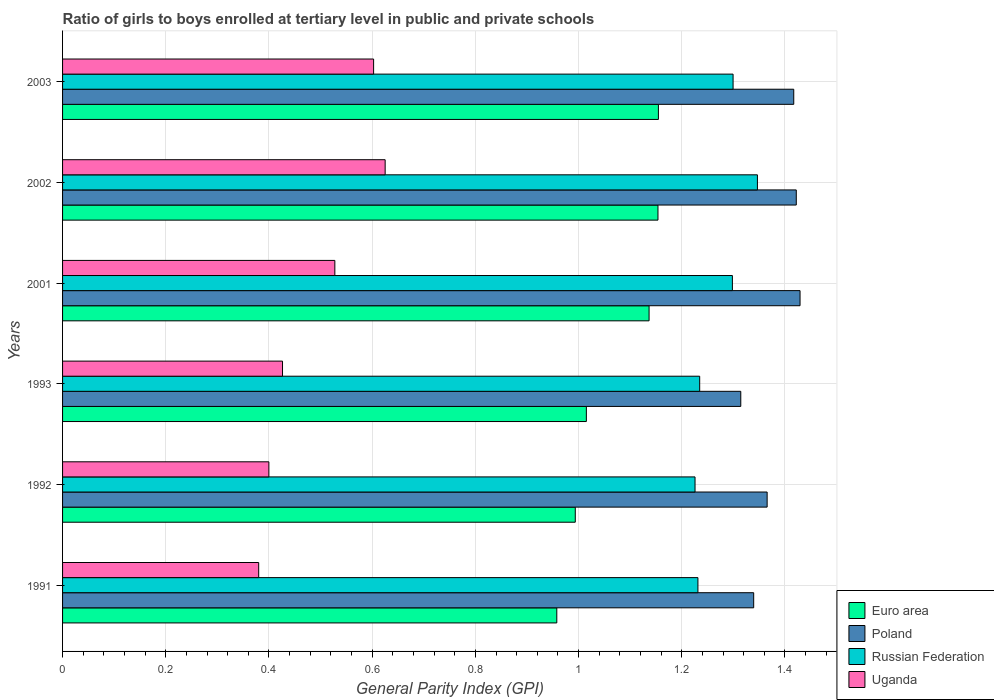How many different coloured bars are there?
Offer a terse response. 4. How many groups of bars are there?
Your response must be concise. 6. Are the number of bars on each tick of the Y-axis equal?
Provide a succinct answer. Yes. How many bars are there on the 6th tick from the bottom?
Offer a very short reply. 4. What is the label of the 5th group of bars from the top?
Your answer should be compact. 1992. In how many cases, is the number of bars for a given year not equal to the number of legend labels?
Ensure brevity in your answer.  0. What is the general parity index in Russian Federation in 1992?
Your response must be concise. 1.23. Across all years, what is the maximum general parity index in Poland?
Make the answer very short. 1.43. Across all years, what is the minimum general parity index in Russian Federation?
Ensure brevity in your answer.  1.23. In which year was the general parity index in Poland maximum?
Make the answer very short. 2001. In which year was the general parity index in Russian Federation minimum?
Your response must be concise. 1992. What is the total general parity index in Uganda in the graph?
Make the answer very short. 2.96. What is the difference between the general parity index in Russian Federation in 2001 and that in 2003?
Your answer should be compact. -0. What is the difference between the general parity index in Poland in 1991 and the general parity index in Uganda in 2001?
Your answer should be compact. 0.81. What is the average general parity index in Poland per year?
Keep it short and to the point. 1.38. In the year 2001, what is the difference between the general parity index in Uganda and general parity index in Euro area?
Give a very brief answer. -0.61. In how many years, is the general parity index in Euro area greater than 1.04 ?
Provide a short and direct response. 3. What is the ratio of the general parity index in Uganda in 1991 to that in 2001?
Give a very brief answer. 0.72. Is the difference between the general parity index in Uganda in 1991 and 2001 greater than the difference between the general parity index in Euro area in 1991 and 2001?
Your answer should be very brief. Yes. What is the difference between the highest and the second highest general parity index in Russian Federation?
Your answer should be compact. 0.05. What is the difference between the highest and the lowest general parity index in Uganda?
Provide a short and direct response. 0.25. Is the sum of the general parity index in Poland in 1991 and 2002 greater than the maximum general parity index in Euro area across all years?
Give a very brief answer. Yes. Is it the case that in every year, the sum of the general parity index in Euro area and general parity index in Uganda is greater than the sum of general parity index in Russian Federation and general parity index in Poland?
Offer a terse response. No. What does the 2nd bar from the top in 1993 represents?
Keep it short and to the point. Russian Federation. What does the 3rd bar from the bottom in 1991 represents?
Your answer should be very brief. Russian Federation. Are the values on the major ticks of X-axis written in scientific E-notation?
Your response must be concise. No. How many legend labels are there?
Offer a very short reply. 4. What is the title of the graph?
Your answer should be compact. Ratio of girls to boys enrolled at tertiary level in public and private schools. What is the label or title of the X-axis?
Give a very brief answer. General Parity Index (GPI). What is the label or title of the Y-axis?
Your response must be concise. Years. What is the General Parity Index (GPI) in Euro area in 1991?
Your answer should be compact. 0.96. What is the General Parity Index (GPI) in Poland in 1991?
Provide a short and direct response. 1.34. What is the General Parity Index (GPI) in Russian Federation in 1991?
Your answer should be compact. 1.23. What is the General Parity Index (GPI) in Uganda in 1991?
Your response must be concise. 0.38. What is the General Parity Index (GPI) in Euro area in 1992?
Provide a succinct answer. 0.99. What is the General Parity Index (GPI) of Poland in 1992?
Provide a succinct answer. 1.37. What is the General Parity Index (GPI) of Russian Federation in 1992?
Your answer should be very brief. 1.23. What is the General Parity Index (GPI) in Uganda in 1992?
Make the answer very short. 0.4. What is the General Parity Index (GPI) in Euro area in 1993?
Provide a succinct answer. 1.02. What is the General Parity Index (GPI) of Poland in 1993?
Provide a short and direct response. 1.31. What is the General Parity Index (GPI) in Russian Federation in 1993?
Your answer should be compact. 1.23. What is the General Parity Index (GPI) in Uganda in 1993?
Offer a very short reply. 0.43. What is the General Parity Index (GPI) in Euro area in 2001?
Keep it short and to the point. 1.14. What is the General Parity Index (GPI) of Poland in 2001?
Offer a very short reply. 1.43. What is the General Parity Index (GPI) of Russian Federation in 2001?
Offer a terse response. 1.3. What is the General Parity Index (GPI) of Uganda in 2001?
Your response must be concise. 0.53. What is the General Parity Index (GPI) in Euro area in 2002?
Your answer should be very brief. 1.15. What is the General Parity Index (GPI) in Poland in 2002?
Offer a terse response. 1.42. What is the General Parity Index (GPI) in Russian Federation in 2002?
Provide a succinct answer. 1.35. What is the General Parity Index (GPI) in Uganda in 2002?
Provide a short and direct response. 0.63. What is the General Parity Index (GPI) in Euro area in 2003?
Give a very brief answer. 1.15. What is the General Parity Index (GPI) of Poland in 2003?
Offer a terse response. 1.42. What is the General Parity Index (GPI) in Russian Federation in 2003?
Offer a terse response. 1.3. What is the General Parity Index (GPI) in Uganda in 2003?
Provide a succinct answer. 0.6. Across all years, what is the maximum General Parity Index (GPI) in Euro area?
Provide a short and direct response. 1.15. Across all years, what is the maximum General Parity Index (GPI) of Poland?
Your answer should be compact. 1.43. Across all years, what is the maximum General Parity Index (GPI) in Russian Federation?
Offer a terse response. 1.35. Across all years, what is the maximum General Parity Index (GPI) of Uganda?
Keep it short and to the point. 0.63. Across all years, what is the minimum General Parity Index (GPI) of Euro area?
Ensure brevity in your answer.  0.96. Across all years, what is the minimum General Parity Index (GPI) of Poland?
Your answer should be compact. 1.31. Across all years, what is the minimum General Parity Index (GPI) of Russian Federation?
Offer a terse response. 1.23. Across all years, what is the minimum General Parity Index (GPI) of Uganda?
Provide a short and direct response. 0.38. What is the total General Parity Index (GPI) of Euro area in the graph?
Your answer should be compact. 6.41. What is the total General Parity Index (GPI) of Poland in the graph?
Keep it short and to the point. 8.29. What is the total General Parity Index (GPI) of Russian Federation in the graph?
Your answer should be compact. 7.64. What is the total General Parity Index (GPI) in Uganda in the graph?
Keep it short and to the point. 2.96. What is the difference between the General Parity Index (GPI) in Euro area in 1991 and that in 1992?
Keep it short and to the point. -0.04. What is the difference between the General Parity Index (GPI) of Poland in 1991 and that in 1992?
Provide a succinct answer. -0.03. What is the difference between the General Parity Index (GPI) of Russian Federation in 1991 and that in 1992?
Keep it short and to the point. 0.01. What is the difference between the General Parity Index (GPI) in Uganda in 1991 and that in 1992?
Your answer should be compact. -0.02. What is the difference between the General Parity Index (GPI) of Euro area in 1991 and that in 1993?
Offer a very short reply. -0.06. What is the difference between the General Parity Index (GPI) in Poland in 1991 and that in 1993?
Provide a succinct answer. 0.03. What is the difference between the General Parity Index (GPI) of Russian Federation in 1991 and that in 1993?
Give a very brief answer. -0. What is the difference between the General Parity Index (GPI) of Uganda in 1991 and that in 1993?
Keep it short and to the point. -0.05. What is the difference between the General Parity Index (GPI) of Euro area in 1991 and that in 2001?
Offer a very short reply. -0.18. What is the difference between the General Parity Index (GPI) in Poland in 1991 and that in 2001?
Your response must be concise. -0.09. What is the difference between the General Parity Index (GPI) of Russian Federation in 1991 and that in 2001?
Offer a very short reply. -0.07. What is the difference between the General Parity Index (GPI) of Uganda in 1991 and that in 2001?
Keep it short and to the point. -0.15. What is the difference between the General Parity Index (GPI) in Euro area in 1991 and that in 2002?
Your response must be concise. -0.2. What is the difference between the General Parity Index (GPI) in Poland in 1991 and that in 2002?
Your response must be concise. -0.08. What is the difference between the General Parity Index (GPI) of Russian Federation in 1991 and that in 2002?
Give a very brief answer. -0.12. What is the difference between the General Parity Index (GPI) of Uganda in 1991 and that in 2002?
Your answer should be compact. -0.25. What is the difference between the General Parity Index (GPI) of Euro area in 1991 and that in 2003?
Your answer should be very brief. -0.2. What is the difference between the General Parity Index (GPI) in Poland in 1991 and that in 2003?
Your answer should be compact. -0.08. What is the difference between the General Parity Index (GPI) of Russian Federation in 1991 and that in 2003?
Give a very brief answer. -0.07. What is the difference between the General Parity Index (GPI) in Uganda in 1991 and that in 2003?
Your answer should be compact. -0.22. What is the difference between the General Parity Index (GPI) in Euro area in 1992 and that in 1993?
Make the answer very short. -0.02. What is the difference between the General Parity Index (GPI) in Poland in 1992 and that in 1993?
Give a very brief answer. 0.05. What is the difference between the General Parity Index (GPI) of Russian Federation in 1992 and that in 1993?
Your response must be concise. -0.01. What is the difference between the General Parity Index (GPI) in Uganda in 1992 and that in 1993?
Offer a terse response. -0.03. What is the difference between the General Parity Index (GPI) of Euro area in 1992 and that in 2001?
Make the answer very short. -0.14. What is the difference between the General Parity Index (GPI) of Poland in 1992 and that in 2001?
Give a very brief answer. -0.06. What is the difference between the General Parity Index (GPI) in Russian Federation in 1992 and that in 2001?
Offer a very short reply. -0.07. What is the difference between the General Parity Index (GPI) in Uganda in 1992 and that in 2001?
Your answer should be compact. -0.13. What is the difference between the General Parity Index (GPI) in Euro area in 1992 and that in 2002?
Ensure brevity in your answer.  -0.16. What is the difference between the General Parity Index (GPI) in Poland in 1992 and that in 2002?
Make the answer very short. -0.06. What is the difference between the General Parity Index (GPI) of Russian Federation in 1992 and that in 2002?
Offer a very short reply. -0.12. What is the difference between the General Parity Index (GPI) in Uganda in 1992 and that in 2002?
Your answer should be compact. -0.23. What is the difference between the General Parity Index (GPI) of Euro area in 1992 and that in 2003?
Keep it short and to the point. -0.16. What is the difference between the General Parity Index (GPI) in Poland in 1992 and that in 2003?
Offer a terse response. -0.05. What is the difference between the General Parity Index (GPI) of Russian Federation in 1992 and that in 2003?
Ensure brevity in your answer.  -0.07. What is the difference between the General Parity Index (GPI) in Uganda in 1992 and that in 2003?
Give a very brief answer. -0.2. What is the difference between the General Parity Index (GPI) of Euro area in 1993 and that in 2001?
Ensure brevity in your answer.  -0.12. What is the difference between the General Parity Index (GPI) in Poland in 1993 and that in 2001?
Your answer should be compact. -0.11. What is the difference between the General Parity Index (GPI) of Russian Federation in 1993 and that in 2001?
Make the answer very short. -0.06. What is the difference between the General Parity Index (GPI) in Uganda in 1993 and that in 2001?
Provide a short and direct response. -0.1. What is the difference between the General Parity Index (GPI) in Euro area in 1993 and that in 2002?
Your answer should be compact. -0.14. What is the difference between the General Parity Index (GPI) in Poland in 1993 and that in 2002?
Offer a very short reply. -0.11. What is the difference between the General Parity Index (GPI) of Russian Federation in 1993 and that in 2002?
Offer a terse response. -0.11. What is the difference between the General Parity Index (GPI) in Uganda in 1993 and that in 2002?
Your response must be concise. -0.2. What is the difference between the General Parity Index (GPI) of Euro area in 1993 and that in 2003?
Offer a very short reply. -0.14. What is the difference between the General Parity Index (GPI) of Poland in 1993 and that in 2003?
Provide a succinct answer. -0.1. What is the difference between the General Parity Index (GPI) of Russian Federation in 1993 and that in 2003?
Make the answer very short. -0.06. What is the difference between the General Parity Index (GPI) of Uganda in 1993 and that in 2003?
Your answer should be very brief. -0.18. What is the difference between the General Parity Index (GPI) in Euro area in 2001 and that in 2002?
Give a very brief answer. -0.02. What is the difference between the General Parity Index (GPI) in Poland in 2001 and that in 2002?
Your response must be concise. 0.01. What is the difference between the General Parity Index (GPI) of Russian Federation in 2001 and that in 2002?
Provide a succinct answer. -0.05. What is the difference between the General Parity Index (GPI) of Uganda in 2001 and that in 2002?
Offer a terse response. -0.1. What is the difference between the General Parity Index (GPI) in Euro area in 2001 and that in 2003?
Provide a succinct answer. -0.02. What is the difference between the General Parity Index (GPI) of Poland in 2001 and that in 2003?
Your response must be concise. 0.01. What is the difference between the General Parity Index (GPI) of Russian Federation in 2001 and that in 2003?
Offer a terse response. -0. What is the difference between the General Parity Index (GPI) in Uganda in 2001 and that in 2003?
Make the answer very short. -0.08. What is the difference between the General Parity Index (GPI) in Euro area in 2002 and that in 2003?
Keep it short and to the point. -0. What is the difference between the General Parity Index (GPI) of Poland in 2002 and that in 2003?
Provide a short and direct response. 0. What is the difference between the General Parity Index (GPI) of Russian Federation in 2002 and that in 2003?
Provide a succinct answer. 0.05. What is the difference between the General Parity Index (GPI) in Uganda in 2002 and that in 2003?
Provide a succinct answer. 0.02. What is the difference between the General Parity Index (GPI) in Euro area in 1991 and the General Parity Index (GPI) in Poland in 1992?
Your answer should be compact. -0.41. What is the difference between the General Parity Index (GPI) of Euro area in 1991 and the General Parity Index (GPI) of Russian Federation in 1992?
Keep it short and to the point. -0.27. What is the difference between the General Parity Index (GPI) in Euro area in 1991 and the General Parity Index (GPI) in Uganda in 1992?
Offer a terse response. 0.56. What is the difference between the General Parity Index (GPI) in Poland in 1991 and the General Parity Index (GPI) in Russian Federation in 1992?
Make the answer very short. 0.11. What is the difference between the General Parity Index (GPI) in Poland in 1991 and the General Parity Index (GPI) in Uganda in 1992?
Ensure brevity in your answer.  0.94. What is the difference between the General Parity Index (GPI) in Russian Federation in 1991 and the General Parity Index (GPI) in Uganda in 1992?
Provide a succinct answer. 0.83. What is the difference between the General Parity Index (GPI) in Euro area in 1991 and the General Parity Index (GPI) in Poland in 1993?
Ensure brevity in your answer.  -0.36. What is the difference between the General Parity Index (GPI) of Euro area in 1991 and the General Parity Index (GPI) of Russian Federation in 1993?
Offer a terse response. -0.28. What is the difference between the General Parity Index (GPI) in Euro area in 1991 and the General Parity Index (GPI) in Uganda in 1993?
Offer a terse response. 0.53. What is the difference between the General Parity Index (GPI) of Poland in 1991 and the General Parity Index (GPI) of Russian Federation in 1993?
Make the answer very short. 0.1. What is the difference between the General Parity Index (GPI) in Poland in 1991 and the General Parity Index (GPI) in Uganda in 1993?
Offer a terse response. 0.91. What is the difference between the General Parity Index (GPI) of Russian Federation in 1991 and the General Parity Index (GPI) of Uganda in 1993?
Keep it short and to the point. 0.81. What is the difference between the General Parity Index (GPI) of Euro area in 1991 and the General Parity Index (GPI) of Poland in 2001?
Provide a succinct answer. -0.47. What is the difference between the General Parity Index (GPI) in Euro area in 1991 and the General Parity Index (GPI) in Russian Federation in 2001?
Give a very brief answer. -0.34. What is the difference between the General Parity Index (GPI) in Euro area in 1991 and the General Parity Index (GPI) in Uganda in 2001?
Ensure brevity in your answer.  0.43. What is the difference between the General Parity Index (GPI) of Poland in 1991 and the General Parity Index (GPI) of Russian Federation in 2001?
Your answer should be very brief. 0.04. What is the difference between the General Parity Index (GPI) of Poland in 1991 and the General Parity Index (GPI) of Uganda in 2001?
Ensure brevity in your answer.  0.81. What is the difference between the General Parity Index (GPI) of Russian Federation in 1991 and the General Parity Index (GPI) of Uganda in 2001?
Provide a succinct answer. 0.7. What is the difference between the General Parity Index (GPI) in Euro area in 1991 and the General Parity Index (GPI) in Poland in 2002?
Give a very brief answer. -0.46. What is the difference between the General Parity Index (GPI) of Euro area in 1991 and the General Parity Index (GPI) of Russian Federation in 2002?
Offer a very short reply. -0.39. What is the difference between the General Parity Index (GPI) in Euro area in 1991 and the General Parity Index (GPI) in Uganda in 2002?
Your answer should be very brief. 0.33. What is the difference between the General Parity Index (GPI) of Poland in 1991 and the General Parity Index (GPI) of Russian Federation in 2002?
Provide a succinct answer. -0.01. What is the difference between the General Parity Index (GPI) in Poland in 1991 and the General Parity Index (GPI) in Uganda in 2002?
Your answer should be very brief. 0.71. What is the difference between the General Parity Index (GPI) of Russian Federation in 1991 and the General Parity Index (GPI) of Uganda in 2002?
Offer a very short reply. 0.61. What is the difference between the General Parity Index (GPI) of Euro area in 1991 and the General Parity Index (GPI) of Poland in 2003?
Offer a terse response. -0.46. What is the difference between the General Parity Index (GPI) in Euro area in 1991 and the General Parity Index (GPI) in Russian Federation in 2003?
Offer a terse response. -0.34. What is the difference between the General Parity Index (GPI) in Euro area in 1991 and the General Parity Index (GPI) in Uganda in 2003?
Keep it short and to the point. 0.35. What is the difference between the General Parity Index (GPI) in Poland in 1991 and the General Parity Index (GPI) in Russian Federation in 2003?
Provide a succinct answer. 0.04. What is the difference between the General Parity Index (GPI) of Poland in 1991 and the General Parity Index (GPI) of Uganda in 2003?
Offer a terse response. 0.74. What is the difference between the General Parity Index (GPI) in Russian Federation in 1991 and the General Parity Index (GPI) in Uganda in 2003?
Keep it short and to the point. 0.63. What is the difference between the General Parity Index (GPI) of Euro area in 1992 and the General Parity Index (GPI) of Poland in 1993?
Keep it short and to the point. -0.32. What is the difference between the General Parity Index (GPI) of Euro area in 1992 and the General Parity Index (GPI) of Russian Federation in 1993?
Your answer should be compact. -0.24. What is the difference between the General Parity Index (GPI) in Euro area in 1992 and the General Parity Index (GPI) in Uganda in 1993?
Provide a succinct answer. 0.57. What is the difference between the General Parity Index (GPI) in Poland in 1992 and the General Parity Index (GPI) in Russian Federation in 1993?
Ensure brevity in your answer.  0.13. What is the difference between the General Parity Index (GPI) of Poland in 1992 and the General Parity Index (GPI) of Uganda in 1993?
Keep it short and to the point. 0.94. What is the difference between the General Parity Index (GPI) in Russian Federation in 1992 and the General Parity Index (GPI) in Uganda in 1993?
Your response must be concise. 0.8. What is the difference between the General Parity Index (GPI) of Euro area in 1992 and the General Parity Index (GPI) of Poland in 2001?
Your response must be concise. -0.44. What is the difference between the General Parity Index (GPI) in Euro area in 1992 and the General Parity Index (GPI) in Russian Federation in 2001?
Ensure brevity in your answer.  -0.3. What is the difference between the General Parity Index (GPI) of Euro area in 1992 and the General Parity Index (GPI) of Uganda in 2001?
Keep it short and to the point. 0.47. What is the difference between the General Parity Index (GPI) in Poland in 1992 and the General Parity Index (GPI) in Russian Federation in 2001?
Provide a short and direct response. 0.07. What is the difference between the General Parity Index (GPI) of Poland in 1992 and the General Parity Index (GPI) of Uganda in 2001?
Offer a very short reply. 0.84. What is the difference between the General Parity Index (GPI) of Russian Federation in 1992 and the General Parity Index (GPI) of Uganda in 2001?
Keep it short and to the point. 0.7. What is the difference between the General Parity Index (GPI) of Euro area in 1992 and the General Parity Index (GPI) of Poland in 2002?
Ensure brevity in your answer.  -0.43. What is the difference between the General Parity Index (GPI) in Euro area in 1992 and the General Parity Index (GPI) in Russian Federation in 2002?
Your answer should be very brief. -0.35. What is the difference between the General Parity Index (GPI) of Euro area in 1992 and the General Parity Index (GPI) of Uganda in 2002?
Offer a very short reply. 0.37. What is the difference between the General Parity Index (GPI) of Poland in 1992 and the General Parity Index (GPI) of Russian Federation in 2002?
Offer a terse response. 0.02. What is the difference between the General Parity Index (GPI) in Poland in 1992 and the General Parity Index (GPI) in Uganda in 2002?
Your answer should be compact. 0.74. What is the difference between the General Parity Index (GPI) in Russian Federation in 1992 and the General Parity Index (GPI) in Uganda in 2002?
Offer a terse response. 0.6. What is the difference between the General Parity Index (GPI) of Euro area in 1992 and the General Parity Index (GPI) of Poland in 2003?
Offer a very short reply. -0.42. What is the difference between the General Parity Index (GPI) of Euro area in 1992 and the General Parity Index (GPI) of Russian Federation in 2003?
Offer a very short reply. -0.31. What is the difference between the General Parity Index (GPI) of Euro area in 1992 and the General Parity Index (GPI) of Uganda in 2003?
Offer a very short reply. 0.39. What is the difference between the General Parity Index (GPI) in Poland in 1992 and the General Parity Index (GPI) in Russian Federation in 2003?
Offer a terse response. 0.07. What is the difference between the General Parity Index (GPI) of Poland in 1992 and the General Parity Index (GPI) of Uganda in 2003?
Make the answer very short. 0.76. What is the difference between the General Parity Index (GPI) in Russian Federation in 1992 and the General Parity Index (GPI) in Uganda in 2003?
Your response must be concise. 0.62. What is the difference between the General Parity Index (GPI) of Euro area in 1993 and the General Parity Index (GPI) of Poland in 2001?
Provide a short and direct response. -0.41. What is the difference between the General Parity Index (GPI) of Euro area in 1993 and the General Parity Index (GPI) of Russian Federation in 2001?
Your response must be concise. -0.28. What is the difference between the General Parity Index (GPI) of Euro area in 1993 and the General Parity Index (GPI) of Uganda in 2001?
Your answer should be very brief. 0.49. What is the difference between the General Parity Index (GPI) in Poland in 1993 and the General Parity Index (GPI) in Russian Federation in 2001?
Give a very brief answer. 0.02. What is the difference between the General Parity Index (GPI) in Poland in 1993 and the General Parity Index (GPI) in Uganda in 2001?
Give a very brief answer. 0.79. What is the difference between the General Parity Index (GPI) in Russian Federation in 1993 and the General Parity Index (GPI) in Uganda in 2001?
Offer a terse response. 0.71. What is the difference between the General Parity Index (GPI) in Euro area in 1993 and the General Parity Index (GPI) in Poland in 2002?
Offer a terse response. -0.41. What is the difference between the General Parity Index (GPI) of Euro area in 1993 and the General Parity Index (GPI) of Russian Federation in 2002?
Your answer should be very brief. -0.33. What is the difference between the General Parity Index (GPI) in Euro area in 1993 and the General Parity Index (GPI) in Uganda in 2002?
Keep it short and to the point. 0.39. What is the difference between the General Parity Index (GPI) in Poland in 1993 and the General Parity Index (GPI) in Russian Federation in 2002?
Keep it short and to the point. -0.03. What is the difference between the General Parity Index (GPI) in Poland in 1993 and the General Parity Index (GPI) in Uganda in 2002?
Your response must be concise. 0.69. What is the difference between the General Parity Index (GPI) of Russian Federation in 1993 and the General Parity Index (GPI) of Uganda in 2002?
Give a very brief answer. 0.61. What is the difference between the General Parity Index (GPI) in Euro area in 1993 and the General Parity Index (GPI) in Poland in 2003?
Ensure brevity in your answer.  -0.4. What is the difference between the General Parity Index (GPI) of Euro area in 1993 and the General Parity Index (GPI) of Russian Federation in 2003?
Your answer should be very brief. -0.28. What is the difference between the General Parity Index (GPI) in Euro area in 1993 and the General Parity Index (GPI) in Uganda in 2003?
Keep it short and to the point. 0.41. What is the difference between the General Parity Index (GPI) of Poland in 1993 and the General Parity Index (GPI) of Russian Federation in 2003?
Offer a very short reply. 0.01. What is the difference between the General Parity Index (GPI) of Poland in 1993 and the General Parity Index (GPI) of Uganda in 2003?
Provide a succinct answer. 0.71. What is the difference between the General Parity Index (GPI) of Russian Federation in 1993 and the General Parity Index (GPI) of Uganda in 2003?
Provide a succinct answer. 0.63. What is the difference between the General Parity Index (GPI) of Euro area in 2001 and the General Parity Index (GPI) of Poland in 2002?
Offer a very short reply. -0.29. What is the difference between the General Parity Index (GPI) of Euro area in 2001 and the General Parity Index (GPI) of Russian Federation in 2002?
Make the answer very short. -0.21. What is the difference between the General Parity Index (GPI) of Euro area in 2001 and the General Parity Index (GPI) of Uganda in 2002?
Your answer should be very brief. 0.51. What is the difference between the General Parity Index (GPI) in Poland in 2001 and the General Parity Index (GPI) in Russian Federation in 2002?
Ensure brevity in your answer.  0.08. What is the difference between the General Parity Index (GPI) in Poland in 2001 and the General Parity Index (GPI) in Uganda in 2002?
Your answer should be compact. 0.8. What is the difference between the General Parity Index (GPI) in Russian Federation in 2001 and the General Parity Index (GPI) in Uganda in 2002?
Ensure brevity in your answer.  0.67. What is the difference between the General Parity Index (GPI) in Euro area in 2001 and the General Parity Index (GPI) in Poland in 2003?
Ensure brevity in your answer.  -0.28. What is the difference between the General Parity Index (GPI) in Euro area in 2001 and the General Parity Index (GPI) in Russian Federation in 2003?
Your response must be concise. -0.16. What is the difference between the General Parity Index (GPI) in Euro area in 2001 and the General Parity Index (GPI) in Uganda in 2003?
Give a very brief answer. 0.53. What is the difference between the General Parity Index (GPI) in Poland in 2001 and the General Parity Index (GPI) in Russian Federation in 2003?
Your answer should be very brief. 0.13. What is the difference between the General Parity Index (GPI) in Poland in 2001 and the General Parity Index (GPI) in Uganda in 2003?
Provide a succinct answer. 0.83. What is the difference between the General Parity Index (GPI) of Russian Federation in 2001 and the General Parity Index (GPI) of Uganda in 2003?
Provide a succinct answer. 0.7. What is the difference between the General Parity Index (GPI) in Euro area in 2002 and the General Parity Index (GPI) in Poland in 2003?
Make the answer very short. -0.26. What is the difference between the General Parity Index (GPI) in Euro area in 2002 and the General Parity Index (GPI) in Russian Federation in 2003?
Your response must be concise. -0.15. What is the difference between the General Parity Index (GPI) of Euro area in 2002 and the General Parity Index (GPI) of Uganda in 2003?
Your answer should be compact. 0.55. What is the difference between the General Parity Index (GPI) of Poland in 2002 and the General Parity Index (GPI) of Russian Federation in 2003?
Your answer should be compact. 0.12. What is the difference between the General Parity Index (GPI) in Poland in 2002 and the General Parity Index (GPI) in Uganda in 2003?
Offer a terse response. 0.82. What is the difference between the General Parity Index (GPI) of Russian Federation in 2002 and the General Parity Index (GPI) of Uganda in 2003?
Keep it short and to the point. 0.74. What is the average General Parity Index (GPI) of Euro area per year?
Provide a succinct answer. 1.07. What is the average General Parity Index (GPI) in Poland per year?
Keep it short and to the point. 1.38. What is the average General Parity Index (GPI) in Russian Federation per year?
Offer a very short reply. 1.27. What is the average General Parity Index (GPI) of Uganda per year?
Make the answer very short. 0.49. In the year 1991, what is the difference between the General Parity Index (GPI) of Euro area and General Parity Index (GPI) of Poland?
Ensure brevity in your answer.  -0.38. In the year 1991, what is the difference between the General Parity Index (GPI) of Euro area and General Parity Index (GPI) of Russian Federation?
Give a very brief answer. -0.27. In the year 1991, what is the difference between the General Parity Index (GPI) of Euro area and General Parity Index (GPI) of Uganda?
Provide a short and direct response. 0.58. In the year 1991, what is the difference between the General Parity Index (GPI) of Poland and General Parity Index (GPI) of Russian Federation?
Offer a very short reply. 0.11. In the year 1991, what is the difference between the General Parity Index (GPI) of Poland and General Parity Index (GPI) of Uganda?
Make the answer very short. 0.96. In the year 1991, what is the difference between the General Parity Index (GPI) in Russian Federation and General Parity Index (GPI) in Uganda?
Provide a short and direct response. 0.85. In the year 1992, what is the difference between the General Parity Index (GPI) in Euro area and General Parity Index (GPI) in Poland?
Provide a succinct answer. -0.37. In the year 1992, what is the difference between the General Parity Index (GPI) in Euro area and General Parity Index (GPI) in Russian Federation?
Provide a short and direct response. -0.23. In the year 1992, what is the difference between the General Parity Index (GPI) in Euro area and General Parity Index (GPI) in Uganda?
Offer a terse response. 0.59. In the year 1992, what is the difference between the General Parity Index (GPI) of Poland and General Parity Index (GPI) of Russian Federation?
Keep it short and to the point. 0.14. In the year 1992, what is the difference between the General Parity Index (GPI) of Poland and General Parity Index (GPI) of Uganda?
Give a very brief answer. 0.97. In the year 1992, what is the difference between the General Parity Index (GPI) of Russian Federation and General Parity Index (GPI) of Uganda?
Provide a short and direct response. 0.83. In the year 1993, what is the difference between the General Parity Index (GPI) of Euro area and General Parity Index (GPI) of Poland?
Your answer should be very brief. -0.3. In the year 1993, what is the difference between the General Parity Index (GPI) in Euro area and General Parity Index (GPI) in Russian Federation?
Your answer should be very brief. -0.22. In the year 1993, what is the difference between the General Parity Index (GPI) in Euro area and General Parity Index (GPI) in Uganda?
Offer a terse response. 0.59. In the year 1993, what is the difference between the General Parity Index (GPI) of Poland and General Parity Index (GPI) of Russian Federation?
Ensure brevity in your answer.  0.08. In the year 1993, what is the difference between the General Parity Index (GPI) in Poland and General Parity Index (GPI) in Uganda?
Provide a short and direct response. 0.89. In the year 1993, what is the difference between the General Parity Index (GPI) of Russian Federation and General Parity Index (GPI) of Uganda?
Offer a very short reply. 0.81. In the year 2001, what is the difference between the General Parity Index (GPI) in Euro area and General Parity Index (GPI) in Poland?
Make the answer very short. -0.29. In the year 2001, what is the difference between the General Parity Index (GPI) in Euro area and General Parity Index (GPI) in Russian Federation?
Provide a short and direct response. -0.16. In the year 2001, what is the difference between the General Parity Index (GPI) in Euro area and General Parity Index (GPI) in Uganda?
Your answer should be compact. 0.61. In the year 2001, what is the difference between the General Parity Index (GPI) in Poland and General Parity Index (GPI) in Russian Federation?
Offer a very short reply. 0.13. In the year 2001, what is the difference between the General Parity Index (GPI) of Poland and General Parity Index (GPI) of Uganda?
Make the answer very short. 0.9. In the year 2001, what is the difference between the General Parity Index (GPI) in Russian Federation and General Parity Index (GPI) in Uganda?
Give a very brief answer. 0.77. In the year 2002, what is the difference between the General Parity Index (GPI) in Euro area and General Parity Index (GPI) in Poland?
Provide a short and direct response. -0.27. In the year 2002, what is the difference between the General Parity Index (GPI) in Euro area and General Parity Index (GPI) in Russian Federation?
Offer a very short reply. -0.19. In the year 2002, what is the difference between the General Parity Index (GPI) of Euro area and General Parity Index (GPI) of Uganda?
Your answer should be compact. 0.53. In the year 2002, what is the difference between the General Parity Index (GPI) of Poland and General Parity Index (GPI) of Russian Federation?
Your answer should be very brief. 0.08. In the year 2002, what is the difference between the General Parity Index (GPI) of Poland and General Parity Index (GPI) of Uganda?
Make the answer very short. 0.8. In the year 2002, what is the difference between the General Parity Index (GPI) in Russian Federation and General Parity Index (GPI) in Uganda?
Provide a succinct answer. 0.72. In the year 2003, what is the difference between the General Parity Index (GPI) of Euro area and General Parity Index (GPI) of Poland?
Provide a short and direct response. -0.26. In the year 2003, what is the difference between the General Parity Index (GPI) in Euro area and General Parity Index (GPI) in Russian Federation?
Provide a short and direct response. -0.14. In the year 2003, what is the difference between the General Parity Index (GPI) in Euro area and General Parity Index (GPI) in Uganda?
Offer a very short reply. 0.55. In the year 2003, what is the difference between the General Parity Index (GPI) in Poland and General Parity Index (GPI) in Russian Federation?
Give a very brief answer. 0.12. In the year 2003, what is the difference between the General Parity Index (GPI) in Poland and General Parity Index (GPI) in Uganda?
Make the answer very short. 0.81. In the year 2003, what is the difference between the General Parity Index (GPI) in Russian Federation and General Parity Index (GPI) in Uganda?
Give a very brief answer. 0.7. What is the ratio of the General Parity Index (GPI) in Euro area in 1991 to that in 1992?
Give a very brief answer. 0.96. What is the ratio of the General Parity Index (GPI) of Poland in 1991 to that in 1992?
Provide a succinct answer. 0.98. What is the ratio of the General Parity Index (GPI) of Russian Federation in 1991 to that in 1992?
Offer a terse response. 1. What is the ratio of the General Parity Index (GPI) in Uganda in 1991 to that in 1992?
Provide a succinct answer. 0.95. What is the ratio of the General Parity Index (GPI) in Euro area in 1991 to that in 1993?
Keep it short and to the point. 0.94. What is the ratio of the General Parity Index (GPI) in Poland in 1991 to that in 1993?
Make the answer very short. 1.02. What is the ratio of the General Parity Index (GPI) of Russian Federation in 1991 to that in 1993?
Offer a terse response. 1. What is the ratio of the General Parity Index (GPI) of Uganda in 1991 to that in 1993?
Ensure brevity in your answer.  0.89. What is the ratio of the General Parity Index (GPI) of Euro area in 1991 to that in 2001?
Provide a short and direct response. 0.84. What is the ratio of the General Parity Index (GPI) of Poland in 1991 to that in 2001?
Give a very brief answer. 0.94. What is the ratio of the General Parity Index (GPI) of Russian Federation in 1991 to that in 2001?
Offer a very short reply. 0.95. What is the ratio of the General Parity Index (GPI) in Uganda in 1991 to that in 2001?
Give a very brief answer. 0.72. What is the ratio of the General Parity Index (GPI) in Euro area in 1991 to that in 2002?
Offer a very short reply. 0.83. What is the ratio of the General Parity Index (GPI) in Poland in 1991 to that in 2002?
Provide a succinct answer. 0.94. What is the ratio of the General Parity Index (GPI) in Russian Federation in 1991 to that in 2002?
Keep it short and to the point. 0.91. What is the ratio of the General Parity Index (GPI) of Uganda in 1991 to that in 2002?
Your answer should be compact. 0.61. What is the ratio of the General Parity Index (GPI) in Euro area in 1991 to that in 2003?
Provide a short and direct response. 0.83. What is the ratio of the General Parity Index (GPI) of Poland in 1991 to that in 2003?
Give a very brief answer. 0.95. What is the ratio of the General Parity Index (GPI) in Russian Federation in 1991 to that in 2003?
Your response must be concise. 0.95. What is the ratio of the General Parity Index (GPI) in Uganda in 1991 to that in 2003?
Offer a very short reply. 0.63. What is the ratio of the General Parity Index (GPI) in Euro area in 1992 to that in 1993?
Your answer should be compact. 0.98. What is the ratio of the General Parity Index (GPI) of Poland in 1992 to that in 1993?
Provide a succinct answer. 1.04. What is the ratio of the General Parity Index (GPI) of Russian Federation in 1992 to that in 1993?
Your answer should be compact. 0.99. What is the ratio of the General Parity Index (GPI) in Uganda in 1992 to that in 1993?
Offer a very short reply. 0.94. What is the ratio of the General Parity Index (GPI) in Euro area in 1992 to that in 2001?
Provide a short and direct response. 0.87. What is the ratio of the General Parity Index (GPI) of Poland in 1992 to that in 2001?
Your answer should be very brief. 0.96. What is the ratio of the General Parity Index (GPI) in Russian Federation in 1992 to that in 2001?
Make the answer very short. 0.94. What is the ratio of the General Parity Index (GPI) in Uganda in 1992 to that in 2001?
Offer a terse response. 0.76. What is the ratio of the General Parity Index (GPI) of Euro area in 1992 to that in 2002?
Your response must be concise. 0.86. What is the ratio of the General Parity Index (GPI) in Poland in 1992 to that in 2002?
Keep it short and to the point. 0.96. What is the ratio of the General Parity Index (GPI) in Russian Federation in 1992 to that in 2002?
Provide a succinct answer. 0.91. What is the ratio of the General Parity Index (GPI) of Uganda in 1992 to that in 2002?
Offer a terse response. 0.64. What is the ratio of the General Parity Index (GPI) in Euro area in 1992 to that in 2003?
Offer a very short reply. 0.86. What is the ratio of the General Parity Index (GPI) of Poland in 1992 to that in 2003?
Provide a short and direct response. 0.96. What is the ratio of the General Parity Index (GPI) of Russian Federation in 1992 to that in 2003?
Offer a terse response. 0.94. What is the ratio of the General Parity Index (GPI) of Uganda in 1992 to that in 2003?
Offer a very short reply. 0.66. What is the ratio of the General Parity Index (GPI) in Euro area in 1993 to that in 2001?
Your answer should be very brief. 0.89. What is the ratio of the General Parity Index (GPI) of Poland in 1993 to that in 2001?
Your answer should be compact. 0.92. What is the ratio of the General Parity Index (GPI) of Russian Federation in 1993 to that in 2001?
Provide a succinct answer. 0.95. What is the ratio of the General Parity Index (GPI) of Uganda in 1993 to that in 2001?
Make the answer very short. 0.81. What is the ratio of the General Parity Index (GPI) in Euro area in 1993 to that in 2002?
Offer a very short reply. 0.88. What is the ratio of the General Parity Index (GPI) of Poland in 1993 to that in 2002?
Keep it short and to the point. 0.92. What is the ratio of the General Parity Index (GPI) of Russian Federation in 1993 to that in 2002?
Keep it short and to the point. 0.92. What is the ratio of the General Parity Index (GPI) in Uganda in 1993 to that in 2002?
Your answer should be compact. 0.68. What is the ratio of the General Parity Index (GPI) in Euro area in 1993 to that in 2003?
Your answer should be compact. 0.88. What is the ratio of the General Parity Index (GPI) in Poland in 1993 to that in 2003?
Your response must be concise. 0.93. What is the ratio of the General Parity Index (GPI) in Russian Federation in 1993 to that in 2003?
Make the answer very short. 0.95. What is the ratio of the General Parity Index (GPI) of Uganda in 1993 to that in 2003?
Provide a short and direct response. 0.71. What is the ratio of the General Parity Index (GPI) in Euro area in 2001 to that in 2002?
Make the answer very short. 0.99. What is the ratio of the General Parity Index (GPI) in Poland in 2001 to that in 2002?
Give a very brief answer. 1.01. What is the ratio of the General Parity Index (GPI) of Uganda in 2001 to that in 2002?
Your response must be concise. 0.84. What is the ratio of the General Parity Index (GPI) in Euro area in 2001 to that in 2003?
Provide a succinct answer. 0.98. What is the ratio of the General Parity Index (GPI) in Poland in 2001 to that in 2003?
Offer a terse response. 1.01. What is the ratio of the General Parity Index (GPI) of Uganda in 2001 to that in 2003?
Provide a succinct answer. 0.88. What is the ratio of the General Parity Index (GPI) of Euro area in 2002 to that in 2003?
Make the answer very short. 1. What is the ratio of the General Parity Index (GPI) in Poland in 2002 to that in 2003?
Your answer should be compact. 1. What is the ratio of the General Parity Index (GPI) in Russian Federation in 2002 to that in 2003?
Your answer should be compact. 1.04. What is the ratio of the General Parity Index (GPI) of Uganda in 2002 to that in 2003?
Make the answer very short. 1.04. What is the difference between the highest and the second highest General Parity Index (GPI) of Euro area?
Offer a very short reply. 0. What is the difference between the highest and the second highest General Parity Index (GPI) in Poland?
Ensure brevity in your answer.  0.01. What is the difference between the highest and the second highest General Parity Index (GPI) of Russian Federation?
Keep it short and to the point. 0.05. What is the difference between the highest and the second highest General Parity Index (GPI) of Uganda?
Provide a succinct answer. 0.02. What is the difference between the highest and the lowest General Parity Index (GPI) in Euro area?
Keep it short and to the point. 0.2. What is the difference between the highest and the lowest General Parity Index (GPI) in Poland?
Your response must be concise. 0.11. What is the difference between the highest and the lowest General Parity Index (GPI) of Russian Federation?
Provide a succinct answer. 0.12. What is the difference between the highest and the lowest General Parity Index (GPI) of Uganda?
Keep it short and to the point. 0.25. 